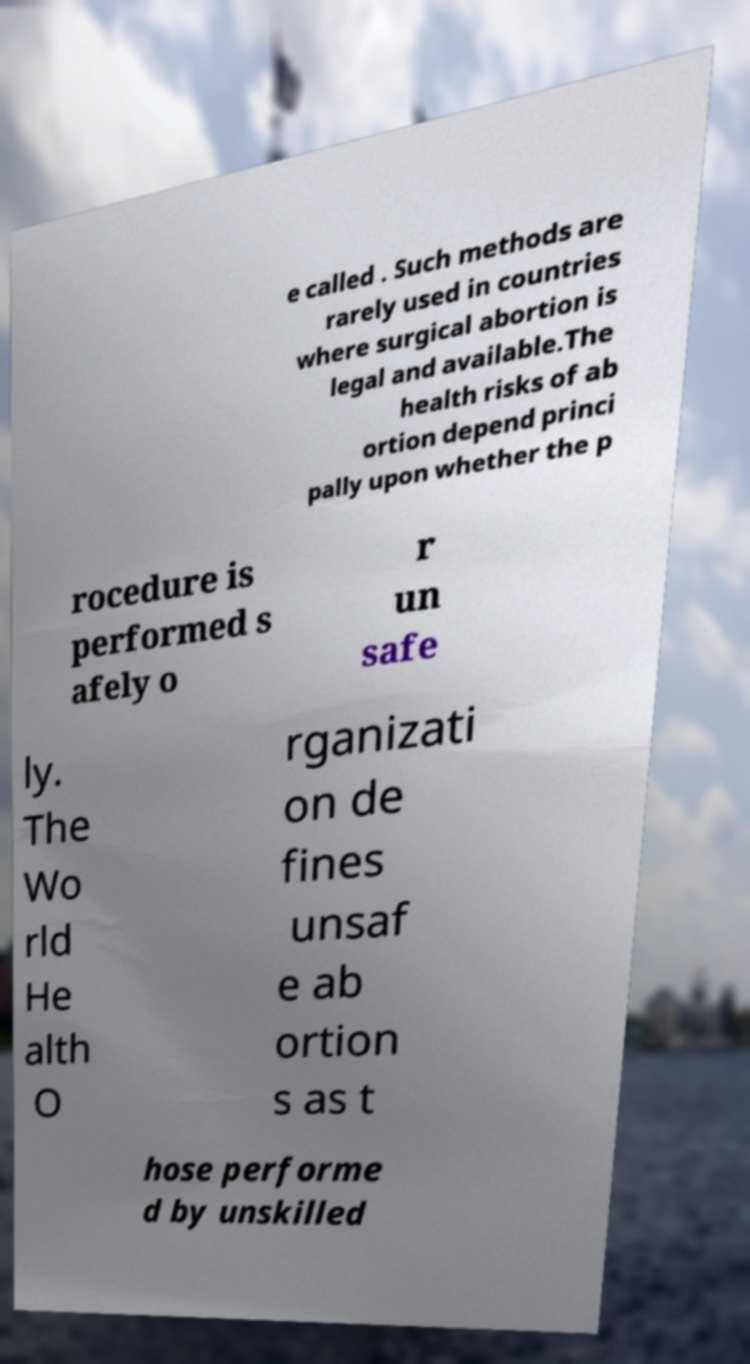Please identify and transcribe the text found in this image. e called . Such methods are rarely used in countries where surgical abortion is legal and available.The health risks of ab ortion depend princi pally upon whether the p rocedure is performed s afely o r un safe ly. The Wo rld He alth O rganizati on de fines unsaf e ab ortion s as t hose performe d by unskilled 